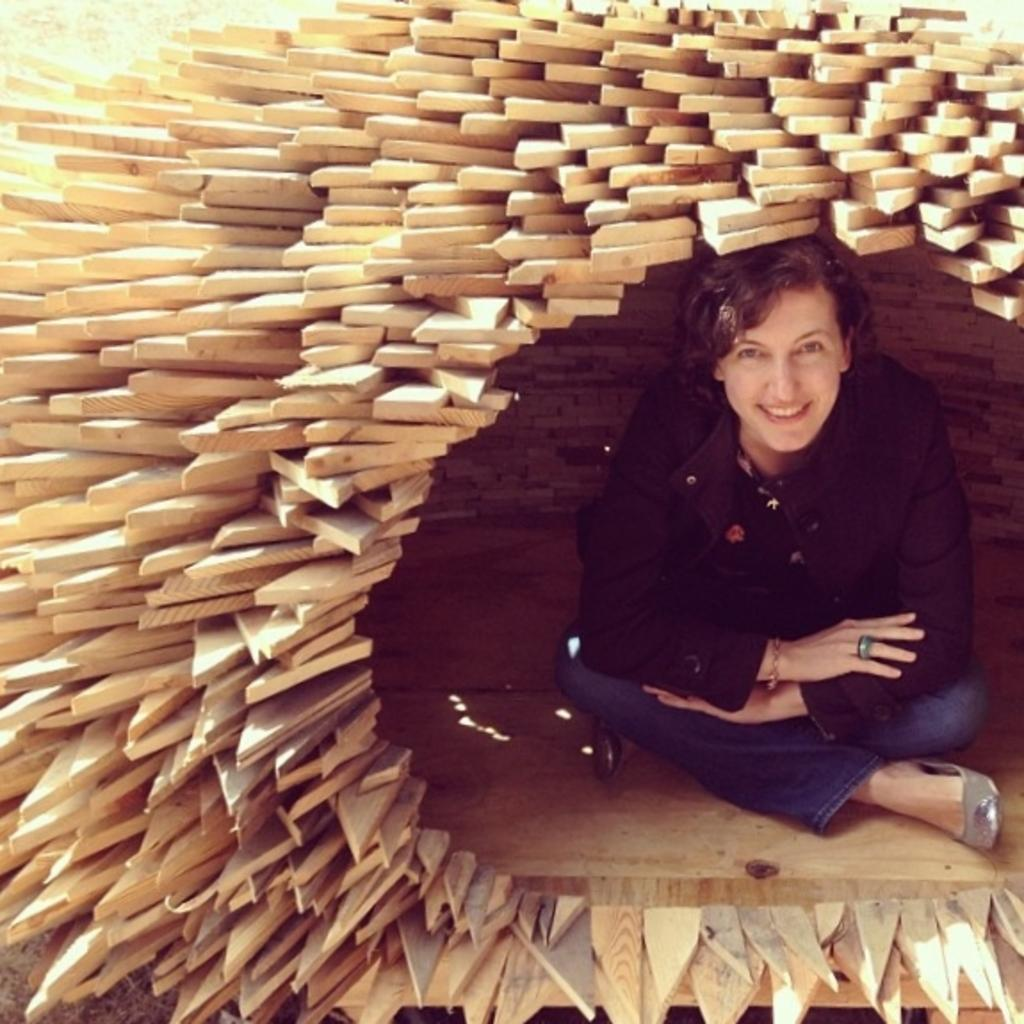What is the main subject of the image? There is a person in the image. What is the person doing in the image? The person is sitting. What is the person's facial expression in the image? The person is smiling. What material is the room made of in the image? The room is made of wood. What type of brush is the person using in the image? There is no brush present in the image. How does the person shake hands with the other person in the image? There is no other person present in the image, and the person is not shaking hands. 